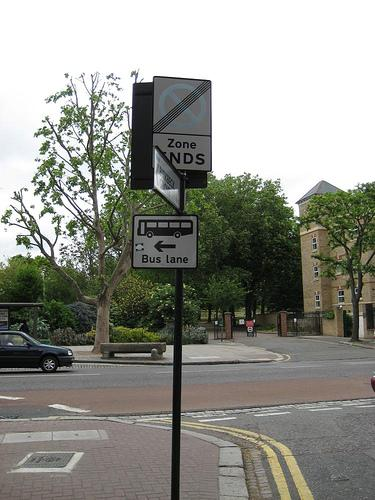What is the sign pointing to? bus lane 